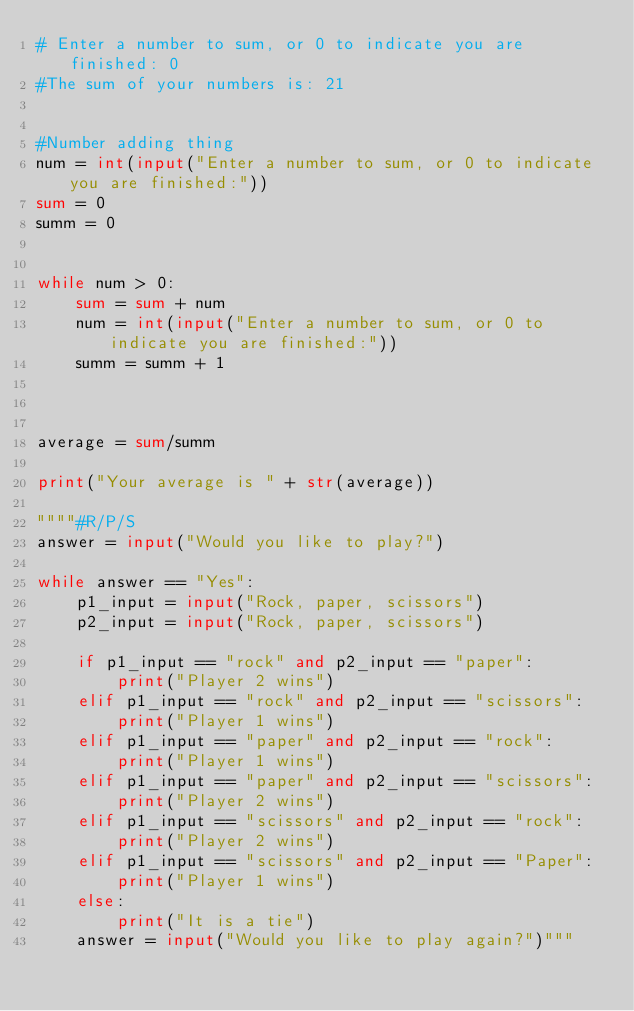Convert code to text. <code><loc_0><loc_0><loc_500><loc_500><_Python_># Enter a number to sum, or 0 to indicate you are finished: 0
#The sum of your numbers is: 21


#Number adding thing
num = int(input("Enter a number to sum, or 0 to indicate you are finished:"))
sum = 0
summ = 0


while num > 0:
    sum = sum + num
    num = int(input("Enter a number to sum, or 0 to indicate you are finished:"))
    summ = summ + 1



average = sum/summ

print("Your average is " + str(average))

""""#R/P/S
answer = input("Would you like to play?")

while answer == "Yes":
    p1_input = input("Rock, paper, scissors")
    p2_input = input("Rock, paper, scissors")

    if p1_input == "rock" and p2_input == "paper":
        print("Player 2 wins")
    elif p1_input == "rock" and p2_input == "scissors":
        print("Player 1 wins")
    elif p1_input == "paper" and p2_input == "rock":
        print("Player 1 wins")
    elif p1_input == "paper" and p2_input == "scissors":
        print("Player 2 wins")
    elif p1_input == "scissors" and p2_input == "rock":
        print("Player 2 wins")
    elif p1_input == "scissors" and p2_input == "Paper":
        print("Player 1 wins")
    else:
        print("It is a tie")
    answer = input("Would you like to play again?")"""












</code> 